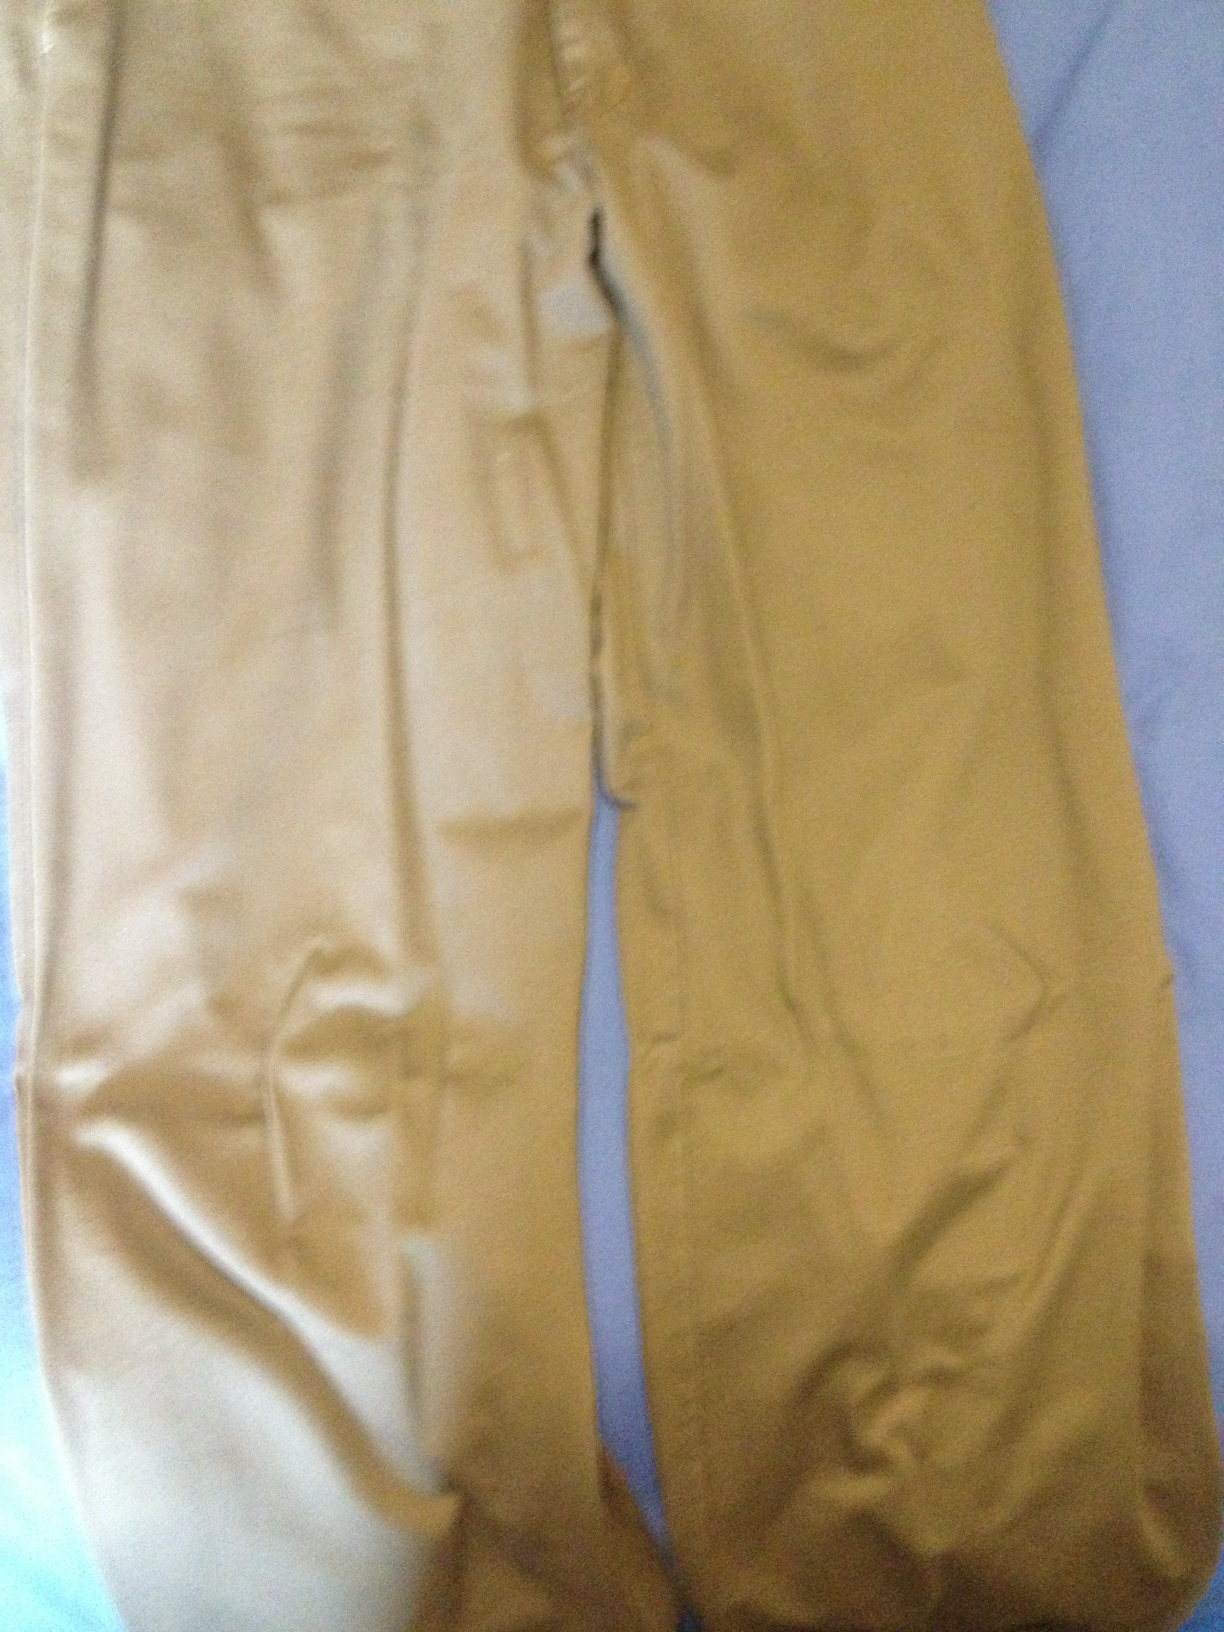What types of tops would pair well with these trousers? These khaki trousers would pair nicely with a wide range of tops. For a casual look, consider a plain white t-shirt or a navy polo. For something more formal, a button-down shirt in a solid color like light blue or a subtle pattern would complement the trousers well. 